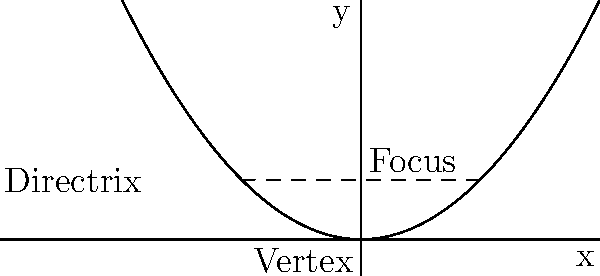In a Romanesque barrel vault, the cross-section can be modeled by a parabola. If the parabola has its vertex at the origin and its focus is 1 unit above the vertex, what is the equation of the directrix? How does this relate to the structural integrity of the vault? To find the equation of the directrix, we'll follow these steps:

1) For a parabola with vertex at $(0,0)$, the general equation is $y = ax^2$, where $a$ is a constant.

2) The distance from the vertex to the focus is equal to the distance from the vertex to the directrix. Given that the focus is 1 unit above the vertex, the directrix must be 1 unit below the vertex.

3) For a parabola with equation $y = ax^2$, the distance from the vertex to the focus is $\frac{1}{4a}$. Therefore:

   $\frac{1}{4a} = 1$
   $a = \frac{1}{4}$

4) The equation of the parabola is thus $y = \frac{1}{4}x^2$.

5) The equation of the directrix is $y = -1$, as it's 1 unit below the x-axis.

Relating to the structural integrity of the vault:

The parabolic shape of the vault distributes the weight evenly along its curve. The focus represents the point where forces converge, while the directrix helps define the curvature. A lower directrix (further from the vertex) results in a flatter arch, which might be less stable but cover a wider span. The chosen parabola with focus at (0,1) and directrix at y=-1 represents a balance between height and span, typical in Romanesque architecture.
Answer: $y = -1$ 